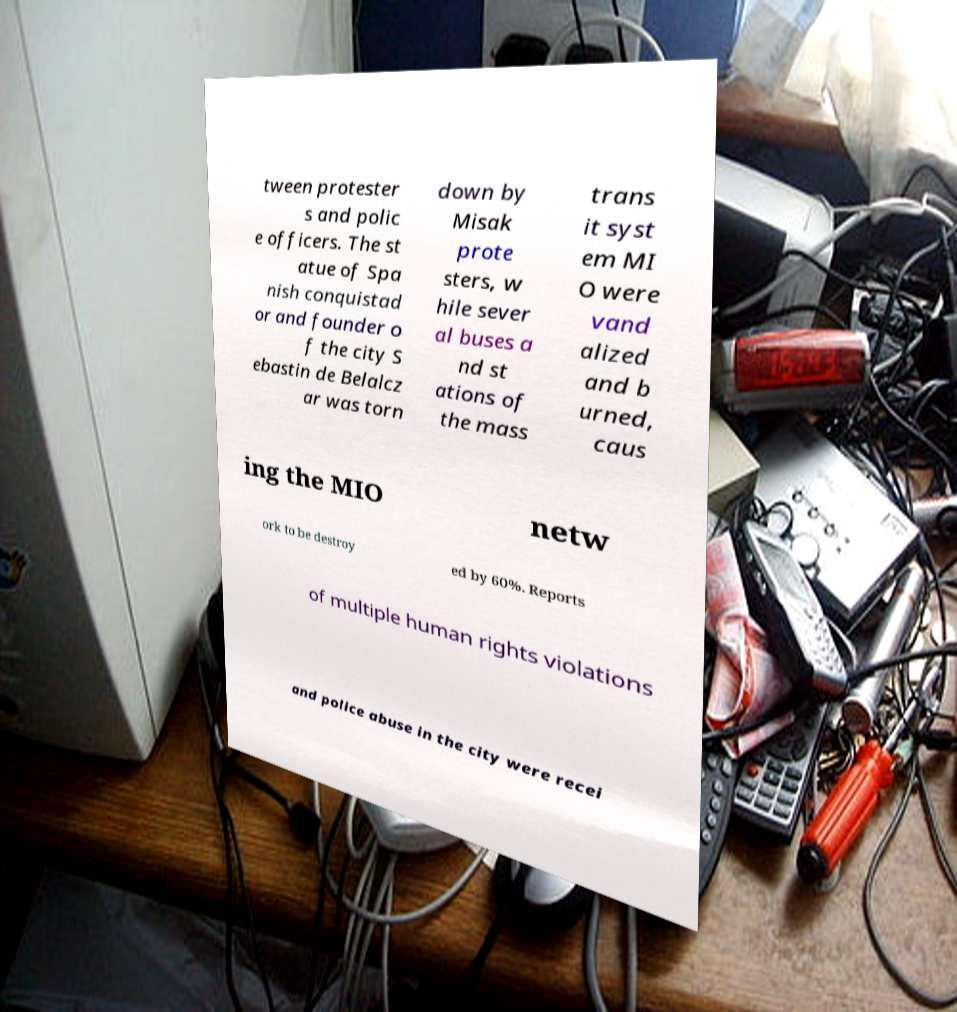Can you read and provide the text displayed in the image?This photo seems to have some interesting text. Can you extract and type it out for me? tween protester s and polic e officers. The st atue of Spa nish conquistad or and founder o f the city S ebastin de Belalcz ar was torn down by Misak prote sters, w hile sever al buses a nd st ations of the mass trans it syst em MI O were vand alized and b urned, caus ing the MIO netw ork to be destroy ed by 60%. Reports of multiple human rights violations and police abuse in the city were recei 